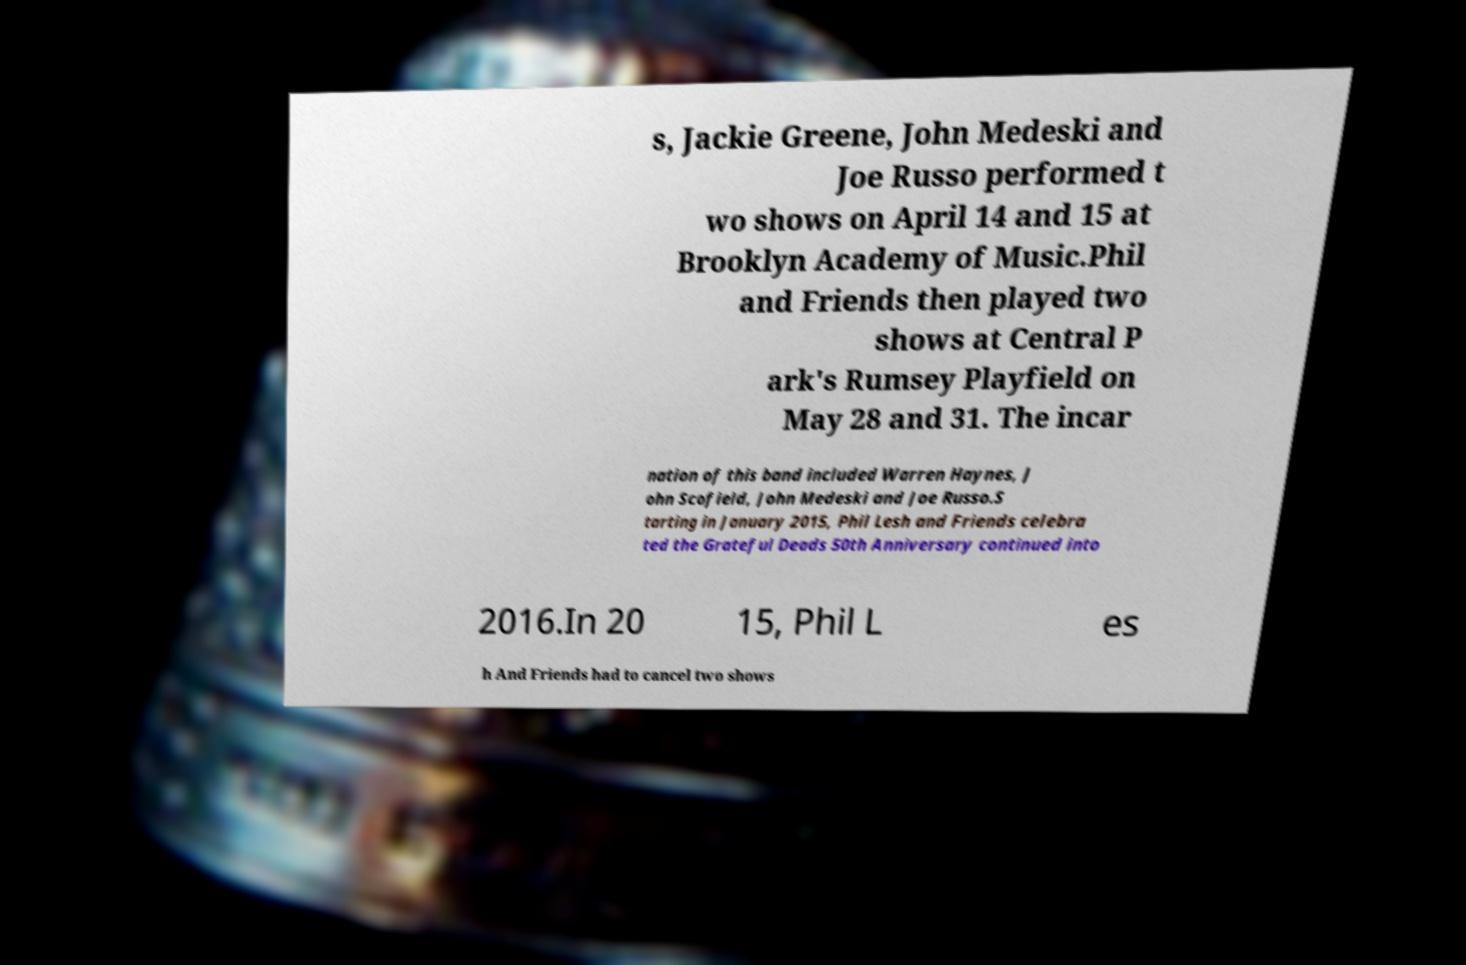Could you extract and type out the text from this image? s, Jackie Greene, John Medeski and Joe Russo performed t wo shows on April 14 and 15 at Brooklyn Academy of Music.Phil and Friends then played two shows at Central P ark's Rumsey Playfield on May 28 and 31. The incar nation of this band included Warren Haynes, J ohn Scofield, John Medeski and Joe Russo.S tarting in January 2015, Phil Lesh and Friends celebra ted the Grateful Deads 50th Anniversary continued into 2016.In 20 15, Phil L es h And Friends had to cancel two shows 